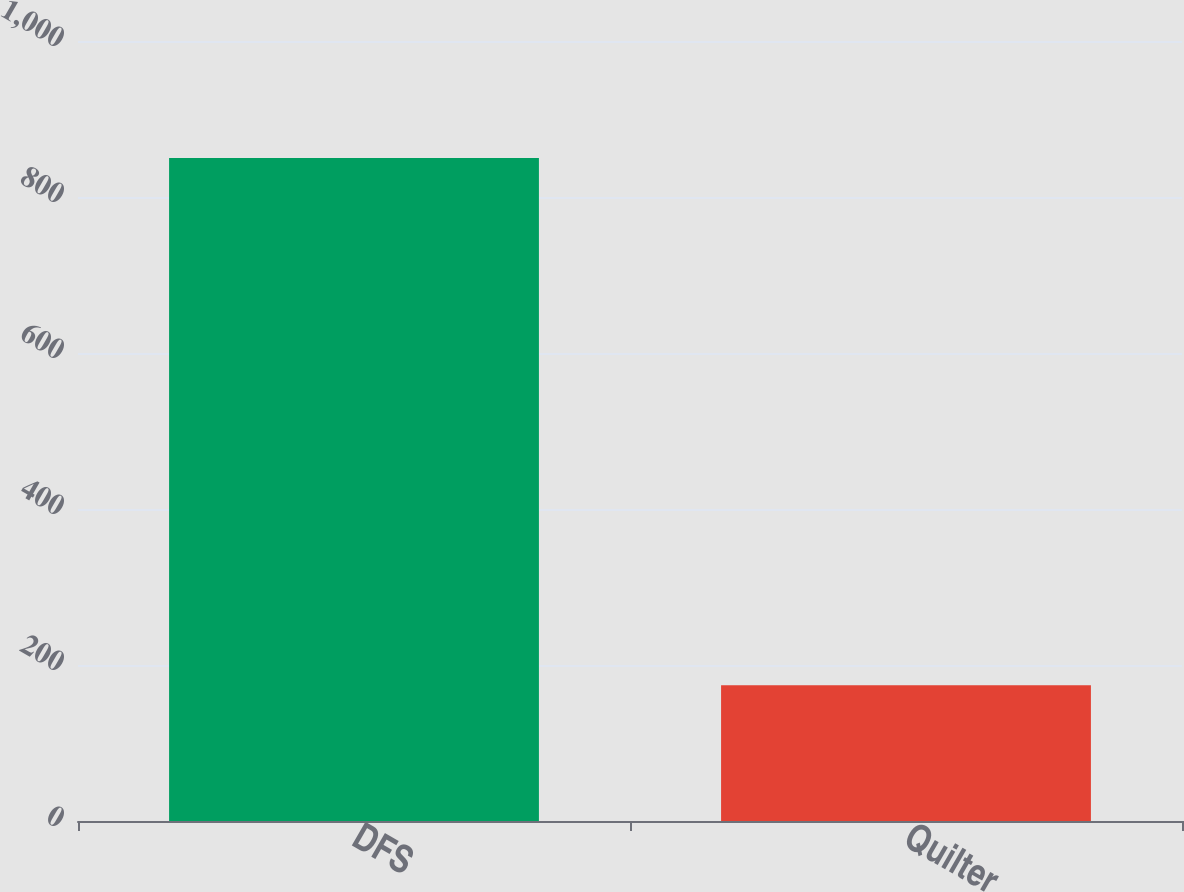<chart> <loc_0><loc_0><loc_500><loc_500><bar_chart><fcel>DFS<fcel>Quilter<nl><fcel>850<fcel>174<nl></chart> 